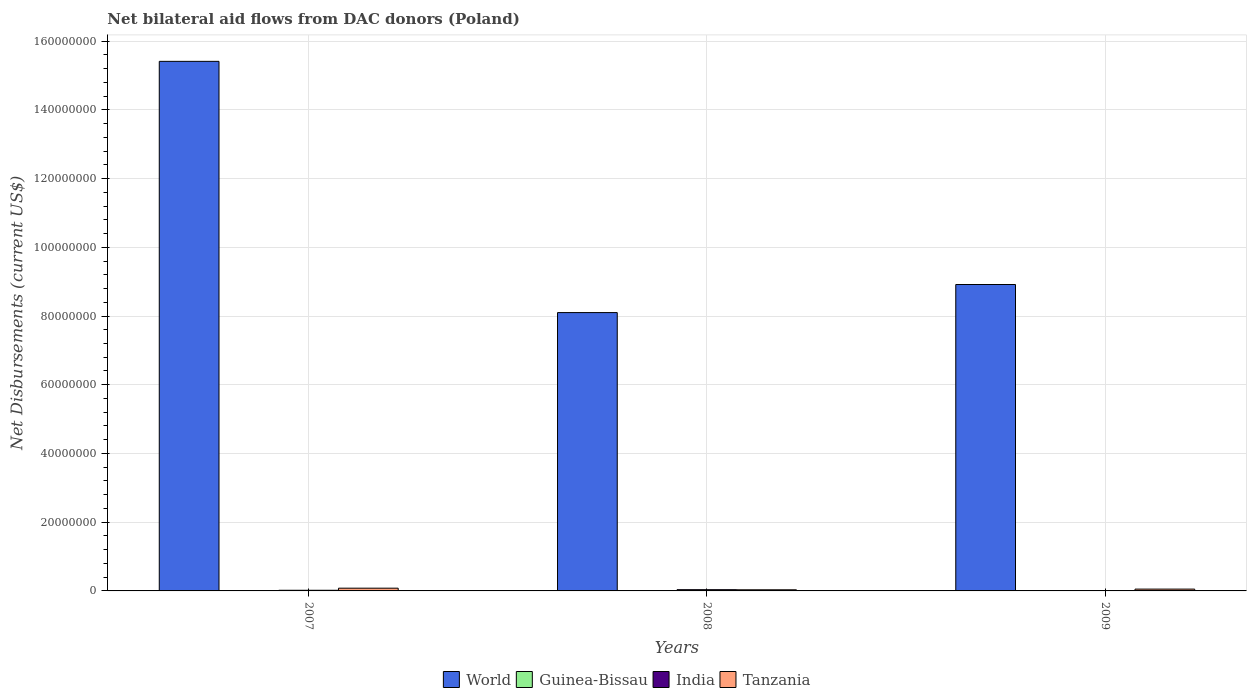How many different coloured bars are there?
Provide a succinct answer. 4. How many groups of bars are there?
Your answer should be very brief. 3. How many bars are there on the 1st tick from the left?
Your response must be concise. 4. What is the label of the 2nd group of bars from the left?
Provide a succinct answer. 2008. What is the net bilateral aid flows in World in 2007?
Make the answer very short. 1.54e+08. Across all years, what is the maximum net bilateral aid flows in India?
Your response must be concise. 3.60e+05. Across all years, what is the minimum net bilateral aid flows in Guinea-Bissau?
Offer a very short reply. 10000. What is the total net bilateral aid flows in World in the graph?
Offer a very short reply. 3.24e+08. In the year 2008, what is the difference between the net bilateral aid flows in India and net bilateral aid flows in World?
Give a very brief answer. -8.06e+07. In how many years, is the net bilateral aid flows in World greater than 20000000 US$?
Offer a terse response. 3. What is the ratio of the net bilateral aid flows in India in 2007 to that in 2009?
Offer a terse response. 1.73. What is the difference between the highest and the lowest net bilateral aid flows in Tanzania?
Provide a succinct answer. 4.70e+05. Is the sum of the net bilateral aid flows in World in 2007 and 2009 greater than the maximum net bilateral aid flows in Guinea-Bissau across all years?
Provide a short and direct response. Yes. Is it the case that in every year, the sum of the net bilateral aid flows in Guinea-Bissau and net bilateral aid flows in Tanzania is greater than the sum of net bilateral aid flows in India and net bilateral aid flows in World?
Your response must be concise. No. What does the 2nd bar from the left in 2008 represents?
Offer a very short reply. Guinea-Bissau. What does the 3rd bar from the right in 2007 represents?
Your answer should be compact. Guinea-Bissau. Is it the case that in every year, the sum of the net bilateral aid flows in Tanzania and net bilateral aid flows in World is greater than the net bilateral aid flows in India?
Give a very brief answer. Yes. How many bars are there?
Offer a very short reply. 12. Are all the bars in the graph horizontal?
Provide a succinct answer. No. Are the values on the major ticks of Y-axis written in scientific E-notation?
Your response must be concise. No. Does the graph contain any zero values?
Your answer should be compact. No. Where does the legend appear in the graph?
Your response must be concise. Bottom center. How many legend labels are there?
Offer a terse response. 4. What is the title of the graph?
Your answer should be very brief. Net bilateral aid flows from DAC donors (Poland). Does "Indonesia" appear as one of the legend labels in the graph?
Give a very brief answer. No. What is the label or title of the Y-axis?
Give a very brief answer. Net Disbursements (current US$). What is the Net Disbursements (current US$) of World in 2007?
Offer a terse response. 1.54e+08. What is the Net Disbursements (current US$) in India in 2007?
Keep it short and to the point. 1.90e+05. What is the Net Disbursements (current US$) of World in 2008?
Offer a very short reply. 8.10e+07. What is the Net Disbursements (current US$) of Guinea-Bissau in 2008?
Offer a terse response. 10000. What is the Net Disbursements (current US$) in India in 2008?
Make the answer very short. 3.60e+05. What is the Net Disbursements (current US$) of Tanzania in 2008?
Your response must be concise. 3.30e+05. What is the Net Disbursements (current US$) of World in 2009?
Keep it short and to the point. 8.92e+07. What is the Net Disbursements (current US$) of Tanzania in 2009?
Offer a terse response. 5.30e+05. Across all years, what is the maximum Net Disbursements (current US$) in World?
Ensure brevity in your answer.  1.54e+08. Across all years, what is the maximum Net Disbursements (current US$) in Guinea-Bissau?
Keep it short and to the point. 10000. Across all years, what is the minimum Net Disbursements (current US$) of World?
Your response must be concise. 8.10e+07. Across all years, what is the minimum Net Disbursements (current US$) of India?
Offer a terse response. 1.10e+05. Across all years, what is the minimum Net Disbursements (current US$) in Tanzania?
Offer a terse response. 3.30e+05. What is the total Net Disbursements (current US$) of World in the graph?
Ensure brevity in your answer.  3.24e+08. What is the total Net Disbursements (current US$) in Guinea-Bissau in the graph?
Offer a very short reply. 3.00e+04. What is the total Net Disbursements (current US$) in Tanzania in the graph?
Offer a very short reply. 1.66e+06. What is the difference between the Net Disbursements (current US$) in World in 2007 and that in 2008?
Make the answer very short. 7.31e+07. What is the difference between the Net Disbursements (current US$) of Tanzania in 2007 and that in 2008?
Your response must be concise. 4.70e+05. What is the difference between the Net Disbursements (current US$) of World in 2007 and that in 2009?
Provide a succinct answer. 6.49e+07. What is the difference between the Net Disbursements (current US$) of India in 2007 and that in 2009?
Offer a very short reply. 8.00e+04. What is the difference between the Net Disbursements (current US$) of World in 2008 and that in 2009?
Ensure brevity in your answer.  -8.17e+06. What is the difference between the Net Disbursements (current US$) in Guinea-Bissau in 2008 and that in 2009?
Give a very brief answer. 0. What is the difference between the Net Disbursements (current US$) in India in 2008 and that in 2009?
Your response must be concise. 2.50e+05. What is the difference between the Net Disbursements (current US$) of World in 2007 and the Net Disbursements (current US$) of Guinea-Bissau in 2008?
Your answer should be very brief. 1.54e+08. What is the difference between the Net Disbursements (current US$) of World in 2007 and the Net Disbursements (current US$) of India in 2008?
Provide a succinct answer. 1.54e+08. What is the difference between the Net Disbursements (current US$) of World in 2007 and the Net Disbursements (current US$) of Tanzania in 2008?
Provide a succinct answer. 1.54e+08. What is the difference between the Net Disbursements (current US$) of Guinea-Bissau in 2007 and the Net Disbursements (current US$) of India in 2008?
Your response must be concise. -3.50e+05. What is the difference between the Net Disbursements (current US$) in Guinea-Bissau in 2007 and the Net Disbursements (current US$) in Tanzania in 2008?
Your answer should be compact. -3.20e+05. What is the difference between the Net Disbursements (current US$) of India in 2007 and the Net Disbursements (current US$) of Tanzania in 2008?
Your answer should be very brief. -1.40e+05. What is the difference between the Net Disbursements (current US$) in World in 2007 and the Net Disbursements (current US$) in Guinea-Bissau in 2009?
Make the answer very short. 1.54e+08. What is the difference between the Net Disbursements (current US$) of World in 2007 and the Net Disbursements (current US$) of India in 2009?
Make the answer very short. 1.54e+08. What is the difference between the Net Disbursements (current US$) of World in 2007 and the Net Disbursements (current US$) of Tanzania in 2009?
Your answer should be compact. 1.54e+08. What is the difference between the Net Disbursements (current US$) in Guinea-Bissau in 2007 and the Net Disbursements (current US$) in Tanzania in 2009?
Your answer should be very brief. -5.20e+05. What is the difference between the Net Disbursements (current US$) of India in 2007 and the Net Disbursements (current US$) of Tanzania in 2009?
Offer a very short reply. -3.40e+05. What is the difference between the Net Disbursements (current US$) in World in 2008 and the Net Disbursements (current US$) in Guinea-Bissau in 2009?
Offer a terse response. 8.10e+07. What is the difference between the Net Disbursements (current US$) in World in 2008 and the Net Disbursements (current US$) in India in 2009?
Provide a succinct answer. 8.09e+07. What is the difference between the Net Disbursements (current US$) in World in 2008 and the Net Disbursements (current US$) in Tanzania in 2009?
Your answer should be compact. 8.05e+07. What is the difference between the Net Disbursements (current US$) in Guinea-Bissau in 2008 and the Net Disbursements (current US$) in India in 2009?
Make the answer very short. -1.00e+05. What is the difference between the Net Disbursements (current US$) in Guinea-Bissau in 2008 and the Net Disbursements (current US$) in Tanzania in 2009?
Provide a succinct answer. -5.20e+05. What is the average Net Disbursements (current US$) of World per year?
Keep it short and to the point. 1.08e+08. What is the average Net Disbursements (current US$) in India per year?
Keep it short and to the point. 2.20e+05. What is the average Net Disbursements (current US$) of Tanzania per year?
Your response must be concise. 5.53e+05. In the year 2007, what is the difference between the Net Disbursements (current US$) of World and Net Disbursements (current US$) of Guinea-Bissau?
Your answer should be very brief. 1.54e+08. In the year 2007, what is the difference between the Net Disbursements (current US$) of World and Net Disbursements (current US$) of India?
Make the answer very short. 1.54e+08. In the year 2007, what is the difference between the Net Disbursements (current US$) of World and Net Disbursements (current US$) of Tanzania?
Make the answer very short. 1.53e+08. In the year 2007, what is the difference between the Net Disbursements (current US$) of Guinea-Bissau and Net Disbursements (current US$) of Tanzania?
Your response must be concise. -7.90e+05. In the year 2007, what is the difference between the Net Disbursements (current US$) in India and Net Disbursements (current US$) in Tanzania?
Your answer should be compact. -6.10e+05. In the year 2008, what is the difference between the Net Disbursements (current US$) in World and Net Disbursements (current US$) in Guinea-Bissau?
Give a very brief answer. 8.10e+07. In the year 2008, what is the difference between the Net Disbursements (current US$) in World and Net Disbursements (current US$) in India?
Offer a terse response. 8.06e+07. In the year 2008, what is the difference between the Net Disbursements (current US$) of World and Net Disbursements (current US$) of Tanzania?
Your answer should be very brief. 8.07e+07. In the year 2008, what is the difference between the Net Disbursements (current US$) of Guinea-Bissau and Net Disbursements (current US$) of India?
Your answer should be very brief. -3.50e+05. In the year 2008, what is the difference between the Net Disbursements (current US$) of Guinea-Bissau and Net Disbursements (current US$) of Tanzania?
Provide a succinct answer. -3.20e+05. In the year 2009, what is the difference between the Net Disbursements (current US$) in World and Net Disbursements (current US$) in Guinea-Bissau?
Your answer should be very brief. 8.92e+07. In the year 2009, what is the difference between the Net Disbursements (current US$) of World and Net Disbursements (current US$) of India?
Keep it short and to the point. 8.91e+07. In the year 2009, what is the difference between the Net Disbursements (current US$) in World and Net Disbursements (current US$) in Tanzania?
Give a very brief answer. 8.86e+07. In the year 2009, what is the difference between the Net Disbursements (current US$) of Guinea-Bissau and Net Disbursements (current US$) of Tanzania?
Provide a succinct answer. -5.20e+05. In the year 2009, what is the difference between the Net Disbursements (current US$) in India and Net Disbursements (current US$) in Tanzania?
Keep it short and to the point. -4.20e+05. What is the ratio of the Net Disbursements (current US$) of World in 2007 to that in 2008?
Provide a short and direct response. 1.9. What is the ratio of the Net Disbursements (current US$) of Guinea-Bissau in 2007 to that in 2008?
Ensure brevity in your answer.  1. What is the ratio of the Net Disbursements (current US$) in India in 2007 to that in 2008?
Offer a very short reply. 0.53. What is the ratio of the Net Disbursements (current US$) in Tanzania in 2007 to that in 2008?
Give a very brief answer. 2.42. What is the ratio of the Net Disbursements (current US$) in World in 2007 to that in 2009?
Provide a short and direct response. 1.73. What is the ratio of the Net Disbursements (current US$) in Guinea-Bissau in 2007 to that in 2009?
Your answer should be very brief. 1. What is the ratio of the Net Disbursements (current US$) in India in 2007 to that in 2009?
Your answer should be very brief. 1.73. What is the ratio of the Net Disbursements (current US$) of Tanzania in 2007 to that in 2009?
Keep it short and to the point. 1.51. What is the ratio of the Net Disbursements (current US$) in World in 2008 to that in 2009?
Keep it short and to the point. 0.91. What is the ratio of the Net Disbursements (current US$) of Guinea-Bissau in 2008 to that in 2009?
Provide a succinct answer. 1. What is the ratio of the Net Disbursements (current US$) of India in 2008 to that in 2009?
Make the answer very short. 3.27. What is the ratio of the Net Disbursements (current US$) in Tanzania in 2008 to that in 2009?
Ensure brevity in your answer.  0.62. What is the difference between the highest and the second highest Net Disbursements (current US$) in World?
Make the answer very short. 6.49e+07. What is the difference between the highest and the second highest Net Disbursements (current US$) of Tanzania?
Ensure brevity in your answer.  2.70e+05. What is the difference between the highest and the lowest Net Disbursements (current US$) of World?
Your answer should be compact. 7.31e+07. What is the difference between the highest and the lowest Net Disbursements (current US$) in Guinea-Bissau?
Make the answer very short. 0. What is the difference between the highest and the lowest Net Disbursements (current US$) of India?
Offer a terse response. 2.50e+05. 